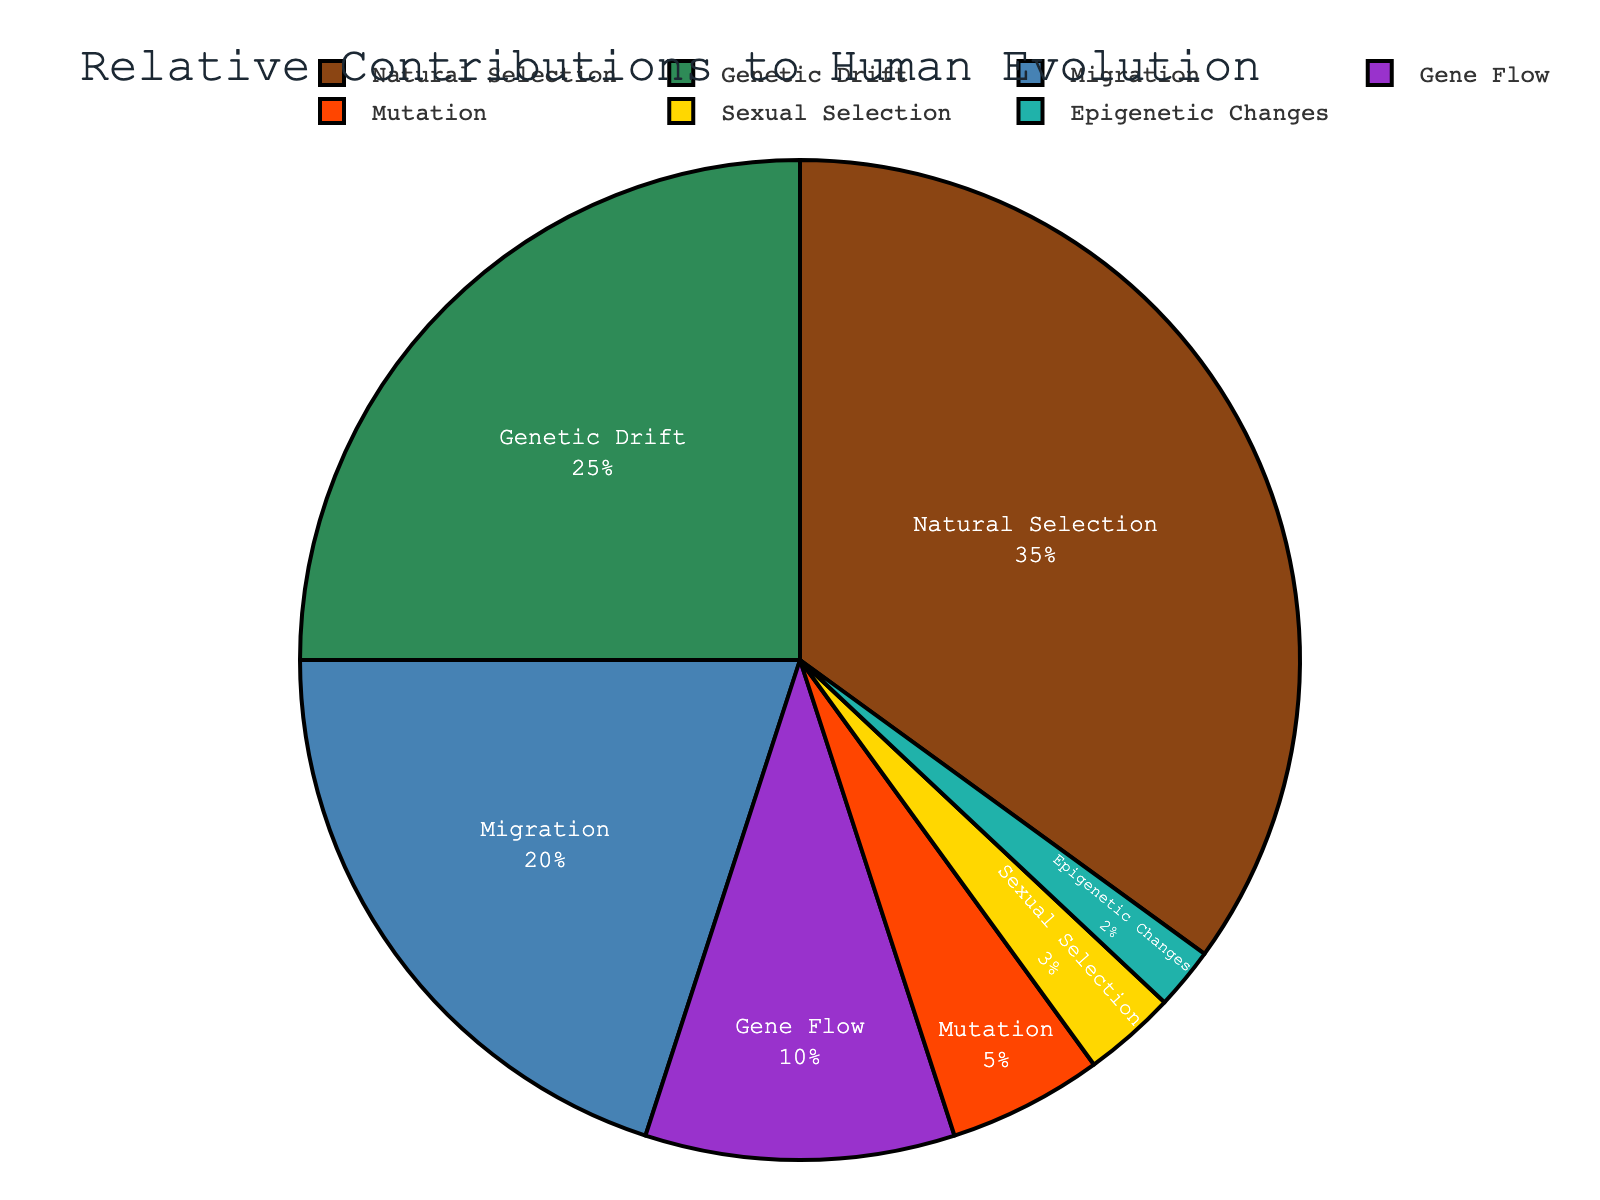What percent of the total contributions is made by the combination of the three least contributing factors? The three least contributing factors are Sexual Selection (3%), Epigenetic Changes (2%), and Mutation (5%). Summing these up: 3% + 2% + 5% = 10%.
Answer: 10% Which factor has a higher contribution: Genetic Drift or Migration? Genetic Drift contributes 25% and Migration contributes 20%. Therefore, Genetic Drift has a higher contribution.
Answer: Genetic Drift What is the combined contribution of Natural Selection and Genetic Drift? Natural Selection contributes 35% and Genetic Drift contributes 25%. Summing these up: 35% + 25% = 60%.
Answer: 60% Which factor is represented by the smallest segment in the pie chart? The segment with the smallest contribution is Epigenetic Changes at 2%.
Answer: Epigenetic Changes What is the percentage difference between the contributions of Mutation and Gene Flow? Mutation contributes 5% and Gene Flow contributes 10%. The difference is calculated as: 10% - 5% = 5%.
Answer: 5% What is the ratio of the contribution of Natural Selection to the contribution of Migration? Natural Selection contributes 35% and Migration contributes 20%. The ratio is calculated as: 35 / 20 = 1.75.
Answer: 1.75 What is the second most significant factor contributing to human evolution according to the pie chart? The second highest contribution after Natural Selection (35%) is Genetic Drift at 25%.
Answer: Genetic Drift If the contributions of Sexual Selection and Epigenetic Changes were combined, would their total contribution exceed that of Mutation? Sexual Selection contributes 3% and Epigenetic Changes contribute 2%. Combined they contribute: 3% + 2% = 5%, which matches but does not exceed the 5% contribution of Mutation.
Answer: No 